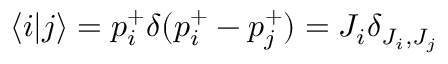<formula> <loc_0><loc_0><loc_500><loc_500>\langle i | j \rangle = p _ { i } ^ { + } \delta ( p _ { i } ^ { + } - p _ { j } ^ { + } ) = J _ { i } \delta _ { J _ { i } , J _ { j } }</formula> 